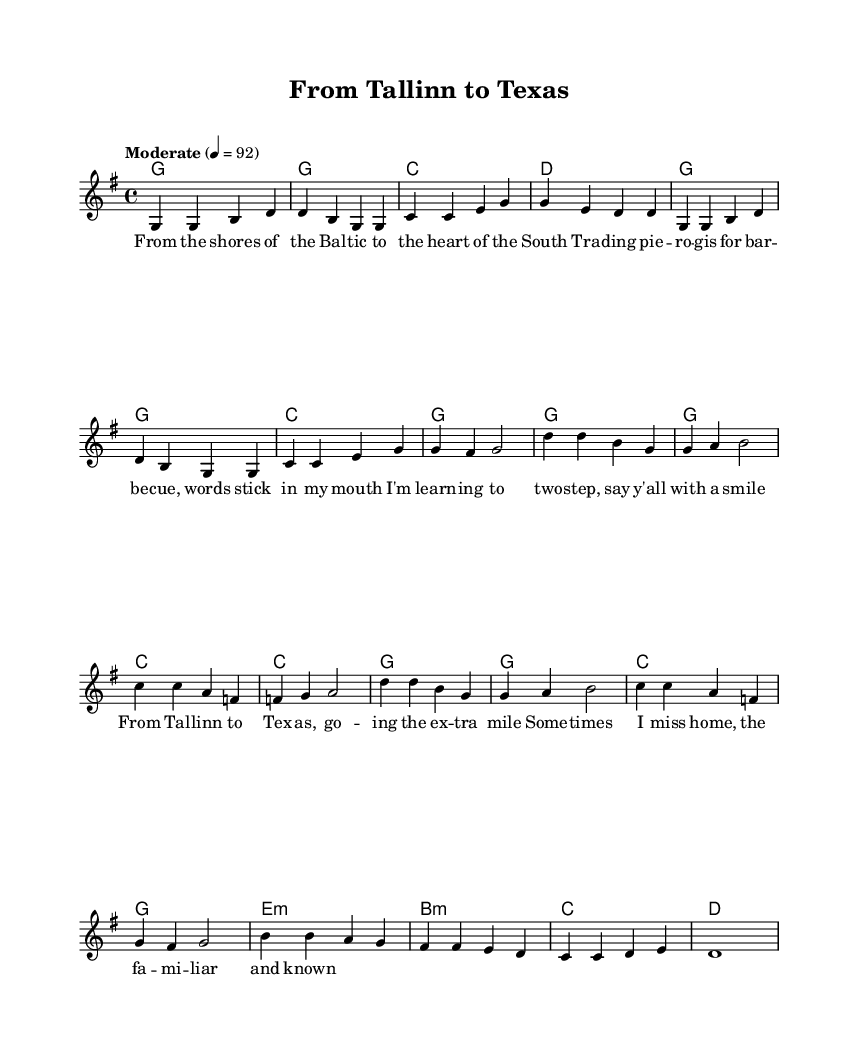What is the time signature of this music? The time signature is indicated at the beginning of the sheet music as 4/4, which means there are four beats per measure and a quarter note receives one beat.
Answer: 4/4 What is the key signature of this music? The key signature is found next to the clef at the beginning of the staff and is marked with one sharp, indicating G major.
Answer: G major What is the tempo marking for this piece? The tempo marking is specified as "Moderate" with a metronome indication of quarter note equals 92, indicating the speed of the piece.
Answer: Moderate 92 How many measures are in the verse section? The verse section can be identified by counting the measures grouped in the melody portion and consists of 8 measures total.
Answer: 8 What are the main themes expressed in the song according to the lyrics? The lyrics reflect themes of cultural adaptation and feelings of homesickness, with particular mentions of trading experiences from Estonia to America, symbolizing a journey.
Answer: Cultural adaptation, homesickness What chords are used in the chorus? By observing the harmony section, the chords in the chorus are G, C, and F, which provide the harmonic support for the melody during that section.
Answer: G, C, F What musical form does this piece follow? The piece follows a common verse-chorus structure, where the verses introduce the narrative and the chorus emphasizes the central themes or emotions of the song.
Answer: Verse-Chorus 